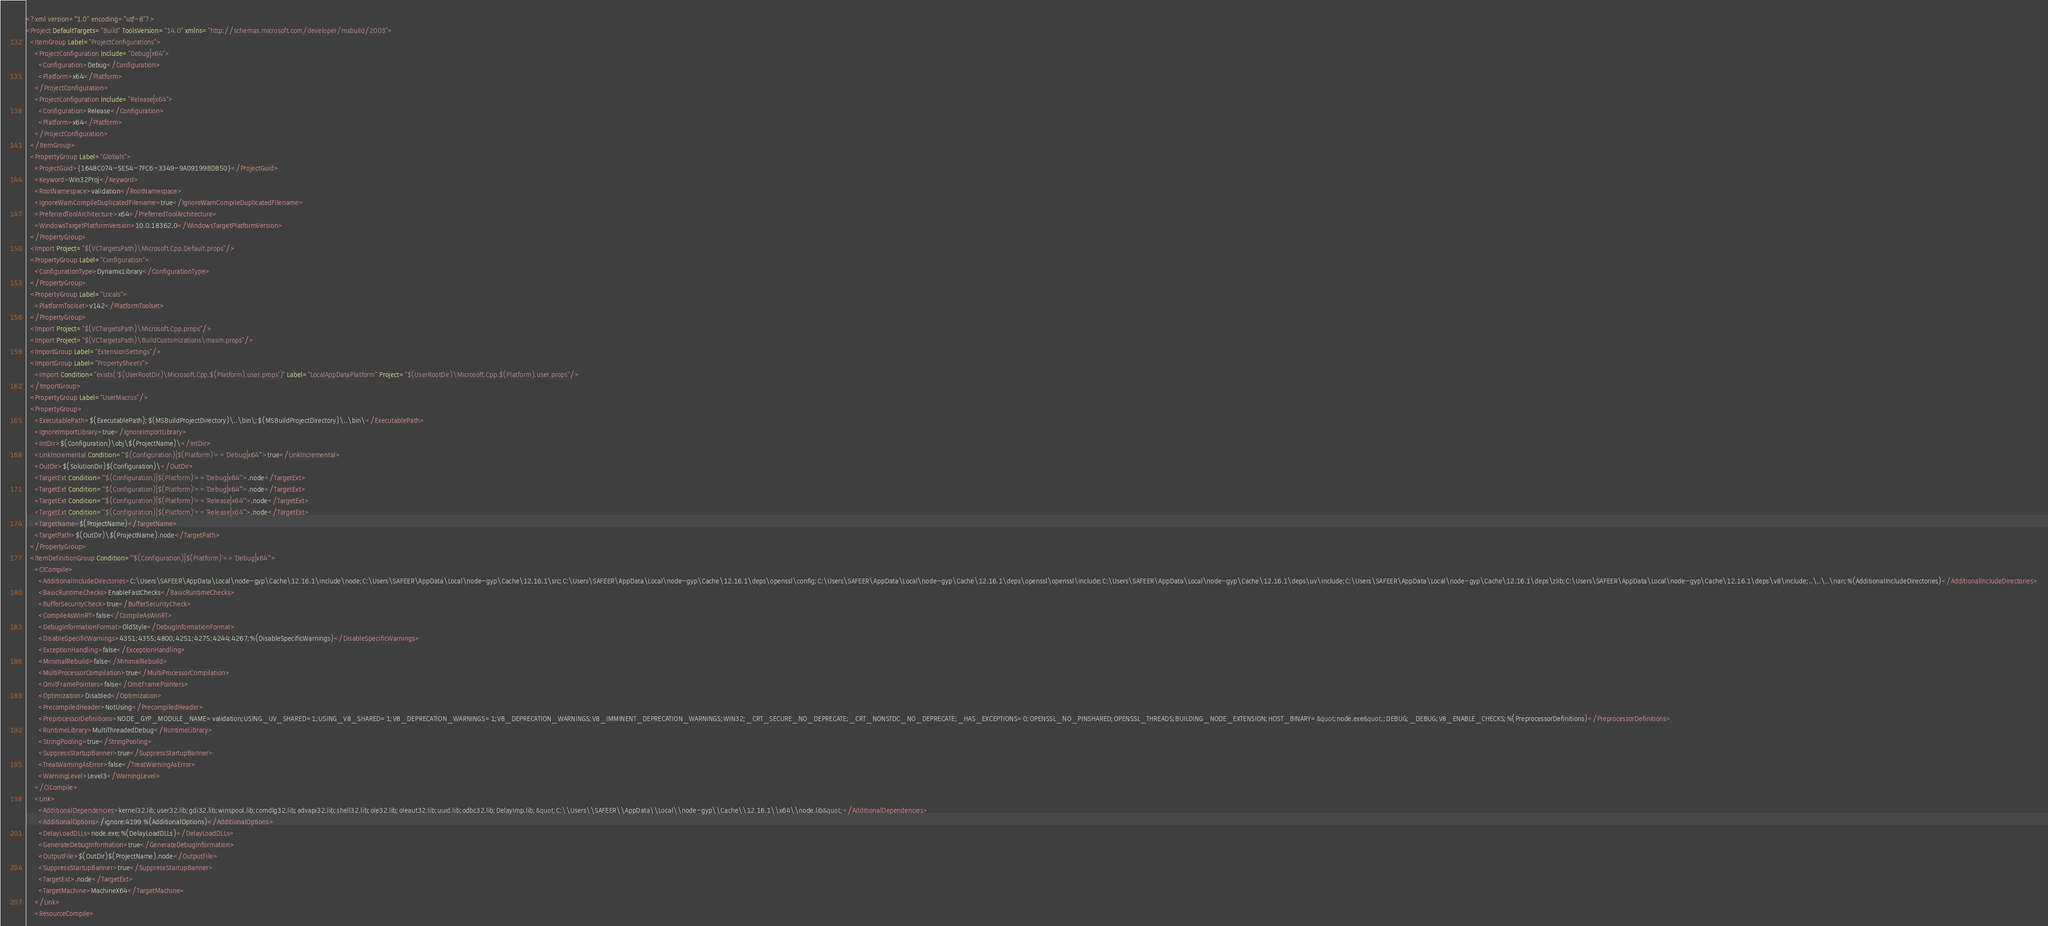<code> <loc_0><loc_0><loc_500><loc_500><_XML_><?xml version="1.0" encoding="utf-8"?>
<Project DefaultTargets="Build" ToolsVersion="14.0" xmlns="http://schemas.microsoft.com/developer/msbuild/2003">
  <ItemGroup Label="ProjectConfigurations">
    <ProjectConfiguration Include="Debug|x64">
      <Configuration>Debug</Configuration>
      <Platform>x64</Platform>
    </ProjectConfiguration>
    <ProjectConfiguration Include="Release|x64">
      <Configuration>Release</Configuration>
      <Platform>x64</Platform>
    </ProjectConfiguration>
  </ItemGroup>
  <PropertyGroup Label="Globals">
    <ProjectGuid>{1648C074-5E54-7FC6-3349-9A09199BDB50}</ProjectGuid>
    <Keyword>Win32Proj</Keyword>
    <RootNamespace>validation</RootNamespace>
    <IgnoreWarnCompileDuplicatedFilename>true</IgnoreWarnCompileDuplicatedFilename>
    <PreferredToolArchitecture>x64</PreferredToolArchitecture>
    <WindowsTargetPlatformVersion>10.0.18362.0</WindowsTargetPlatformVersion>
  </PropertyGroup>
  <Import Project="$(VCTargetsPath)\Microsoft.Cpp.Default.props"/>
  <PropertyGroup Label="Configuration">
    <ConfigurationType>DynamicLibrary</ConfigurationType>
  </PropertyGroup>
  <PropertyGroup Label="Locals">
    <PlatformToolset>v142</PlatformToolset>
  </PropertyGroup>
  <Import Project="$(VCTargetsPath)\Microsoft.Cpp.props"/>
  <Import Project="$(VCTargetsPath)\BuildCustomizations\masm.props"/>
  <ImportGroup Label="ExtensionSettings"/>
  <ImportGroup Label="PropertySheets">
    <Import Condition="exists('$(UserRootDir)\Microsoft.Cpp.$(Platform).user.props')" Label="LocalAppDataPlatform" Project="$(UserRootDir)\Microsoft.Cpp.$(Platform).user.props"/>
  </ImportGroup>
  <PropertyGroup Label="UserMacros"/>
  <PropertyGroup>
    <ExecutablePath>$(ExecutablePath);$(MSBuildProjectDirectory)\..\bin\;$(MSBuildProjectDirectory)\..\bin\</ExecutablePath>
    <IgnoreImportLibrary>true</IgnoreImportLibrary>
    <IntDir>$(Configuration)\obj\$(ProjectName)\</IntDir>
    <LinkIncremental Condition="'$(Configuration)|$(Platform)'=='Debug|x64'">true</LinkIncremental>
    <OutDir>$(SolutionDir)$(Configuration)\</OutDir>
    <TargetExt Condition="'$(Configuration)|$(Platform)'=='Debug|x64'">.node</TargetExt>
    <TargetExt Condition="'$(Configuration)|$(Platform)'=='Debug|x64'">.node</TargetExt>
    <TargetExt Condition="'$(Configuration)|$(Platform)'=='Release|x64'">.node</TargetExt>
    <TargetExt Condition="'$(Configuration)|$(Platform)'=='Release|x64'">.node</TargetExt>
    <TargetName>$(ProjectName)</TargetName>
    <TargetPath>$(OutDir)\$(ProjectName).node</TargetPath>
  </PropertyGroup>
  <ItemDefinitionGroup Condition="'$(Configuration)|$(Platform)'=='Debug|x64'">
    <ClCompile>
      <AdditionalIncludeDirectories>C:\Users\SAFEER\AppData\Local\node-gyp\Cache\12.16.1\include\node;C:\Users\SAFEER\AppData\Local\node-gyp\Cache\12.16.1\src;C:\Users\SAFEER\AppData\Local\node-gyp\Cache\12.16.1\deps\openssl\config;C:\Users\SAFEER\AppData\Local\node-gyp\Cache\12.16.1\deps\openssl\openssl\include;C:\Users\SAFEER\AppData\Local\node-gyp\Cache\12.16.1\deps\uv\include;C:\Users\SAFEER\AppData\Local\node-gyp\Cache\12.16.1\deps\zlib;C:\Users\SAFEER\AppData\Local\node-gyp\Cache\12.16.1\deps\v8\include;..\..\..\nan;%(AdditionalIncludeDirectories)</AdditionalIncludeDirectories>
      <BasicRuntimeChecks>EnableFastChecks</BasicRuntimeChecks>
      <BufferSecurityCheck>true</BufferSecurityCheck>
      <CompileAsWinRT>false</CompileAsWinRT>
      <DebugInformationFormat>OldStyle</DebugInformationFormat>
      <DisableSpecificWarnings>4351;4355;4800;4251;4275;4244;4267;%(DisableSpecificWarnings)</DisableSpecificWarnings>
      <ExceptionHandling>false</ExceptionHandling>
      <MinimalRebuild>false</MinimalRebuild>
      <MultiProcessorCompilation>true</MultiProcessorCompilation>
      <OmitFramePointers>false</OmitFramePointers>
      <Optimization>Disabled</Optimization>
      <PrecompiledHeader>NotUsing</PrecompiledHeader>
      <PreprocessorDefinitions>NODE_GYP_MODULE_NAME=validation;USING_UV_SHARED=1;USING_V8_SHARED=1;V8_DEPRECATION_WARNINGS=1;V8_DEPRECATION_WARNINGS;V8_IMMINENT_DEPRECATION_WARNINGS;WIN32;_CRT_SECURE_NO_DEPRECATE;_CRT_NONSTDC_NO_DEPRECATE;_HAS_EXCEPTIONS=0;OPENSSL_NO_PINSHARED;OPENSSL_THREADS;BUILDING_NODE_EXTENSION;HOST_BINARY=&quot;node.exe&quot;;DEBUG;_DEBUG;V8_ENABLE_CHECKS;%(PreprocessorDefinitions)</PreprocessorDefinitions>
      <RuntimeLibrary>MultiThreadedDebug</RuntimeLibrary>
      <StringPooling>true</StringPooling>
      <SuppressStartupBanner>true</SuppressStartupBanner>
      <TreatWarningAsError>false</TreatWarningAsError>
      <WarningLevel>Level3</WarningLevel>
    </ClCompile>
    <Link>
      <AdditionalDependencies>kernel32.lib;user32.lib;gdi32.lib;winspool.lib;comdlg32.lib;advapi32.lib;shell32.lib;ole32.lib;oleaut32.lib;uuid.lib;odbc32.lib;DelayImp.lib;&quot;C:\\Users\\SAFEER\\AppData\\Local\\node-gyp\\Cache\\12.16.1\\x64\\node.lib&quot;</AdditionalDependencies>
      <AdditionalOptions>/ignore:4199 %(AdditionalOptions)</AdditionalOptions>
      <DelayLoadDLLs>node.exe;%(DelayLoadDLLs)</DelayLoadDLLs>
      <GenerateDebugInformation>true</GenerateDebugInformation>
      <OutputFile>$(OutDir)$(ProjectName).node</OutputFile>
      <SuppressStartupBanner>true</SuppressStartupBanner>
      <TargetExt>.node</TargetExt>
      <TargetMachine>MachineX64</TargetMachine>
    </Link>
    <ResourceCompile></code> 